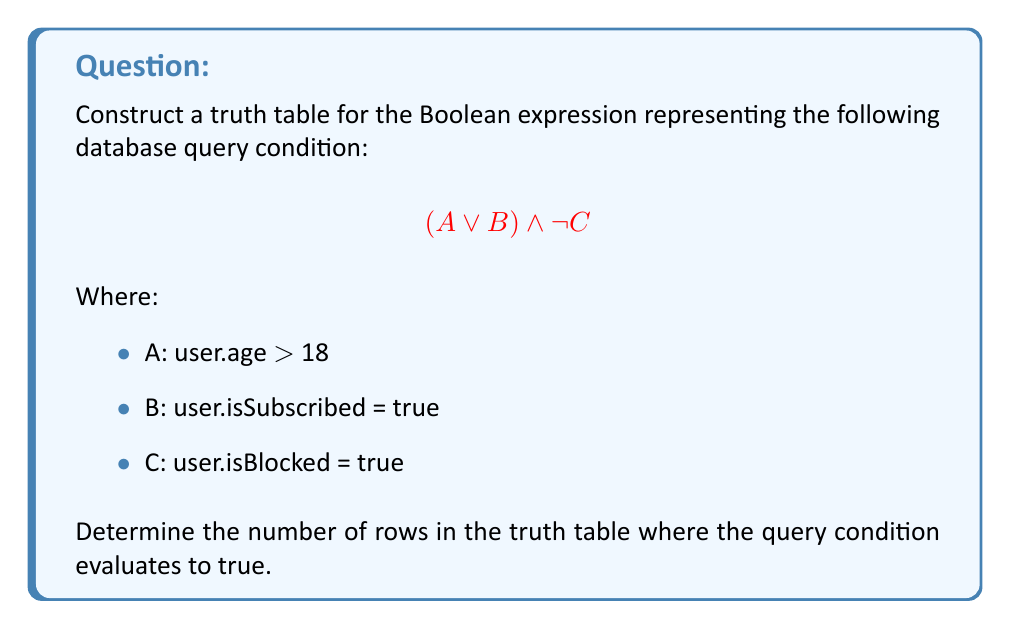Show me your answer to this math problem. Let's approach this step-by-step:

1) First, we need to construct the truth table. The table will have 3 input variables (A, B, and C) and 4 columns for intermediate and final results:

   A | B | C | (A ∨ B) | ¬C | (A ∨ B) ∧ ¬C

2) We'll have $2^3 = 8$ rows in our truth table (excluding the header), as we have 3 input variables.

3) Let's fill in the truth table:

   A | B | C | (A ∨ B) | ¬C | (A ∨ B) ∧ ¬C
   ------------------------------------
   0 | 0 | 0 |    0    |  1  |     0
   0 | 0 | 1 |    0    |  0  |     0
   0 | 1 | 0 |    1    |  1  |     1
   0 | 1 | 1 |    1    |  0  |     0
   1 | 0 | 0 |    1    |  1  |     1
   1 | 0 | 1 |    1    |  0  |     0
   1 | 1 | 0 |    1    |  1  |     1
   1 | 1 | 1 |    1    |  0  |     0

4) Now, we need to count the number of rows where the final column (A ∨ B) ∧ ¬C is true (1).

5) Counting the 1's in the final column, we get 3 rows where the condition is true.

In terms of the database query, this means the condition will be true when:
- The user is over 18 (A is true) and not blocked (C is false)
- The user is subscribed (B is true) and not blocked (C is false)
- Both conditions above are met simultaneously

This aligns with how we might use such a condition in a PHP ORM query to filter users.
Answer: 3 rows in the truth table evaluate to true for the given Boolean expression. 